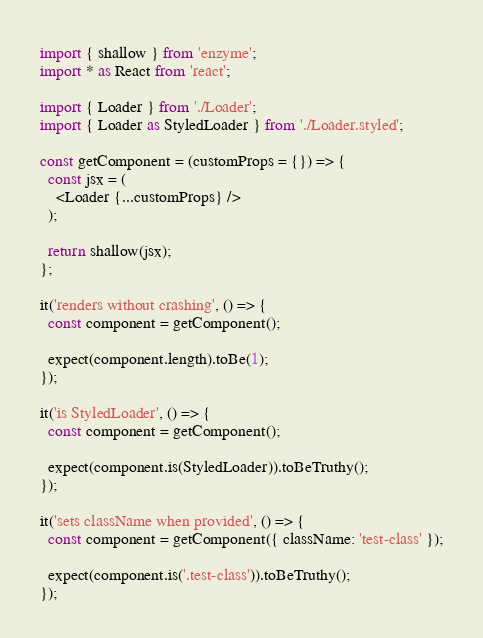<code> <loc_0><loc_0><loc_500><loc_500><_TypeScript_>import { shallow } from 'enzyme';
import * as React from 'react';

import { Loader } from './Loader';
import { Loader as StyledLoader } from './Loader.styled';

const getComponent = (customProps = {}) => {
  const jsx = (
    <Loader {...customProps} />
  );

  return shallow(jsx);
};

it('renders without crashing', () => {
  const component = getComponent();

  expect(component.length).toBe(1);
});

it('is StyledLoader', () => {
  const component = getComponent();

  expect(component.is(StyledLoader)).toBeTruthy();
});

it('sets className when provided', () => {
  const component = getComponent({ className: 'test-class' });

  expect(component.is('.test-class')).toBeTruthy();
});
</code> 